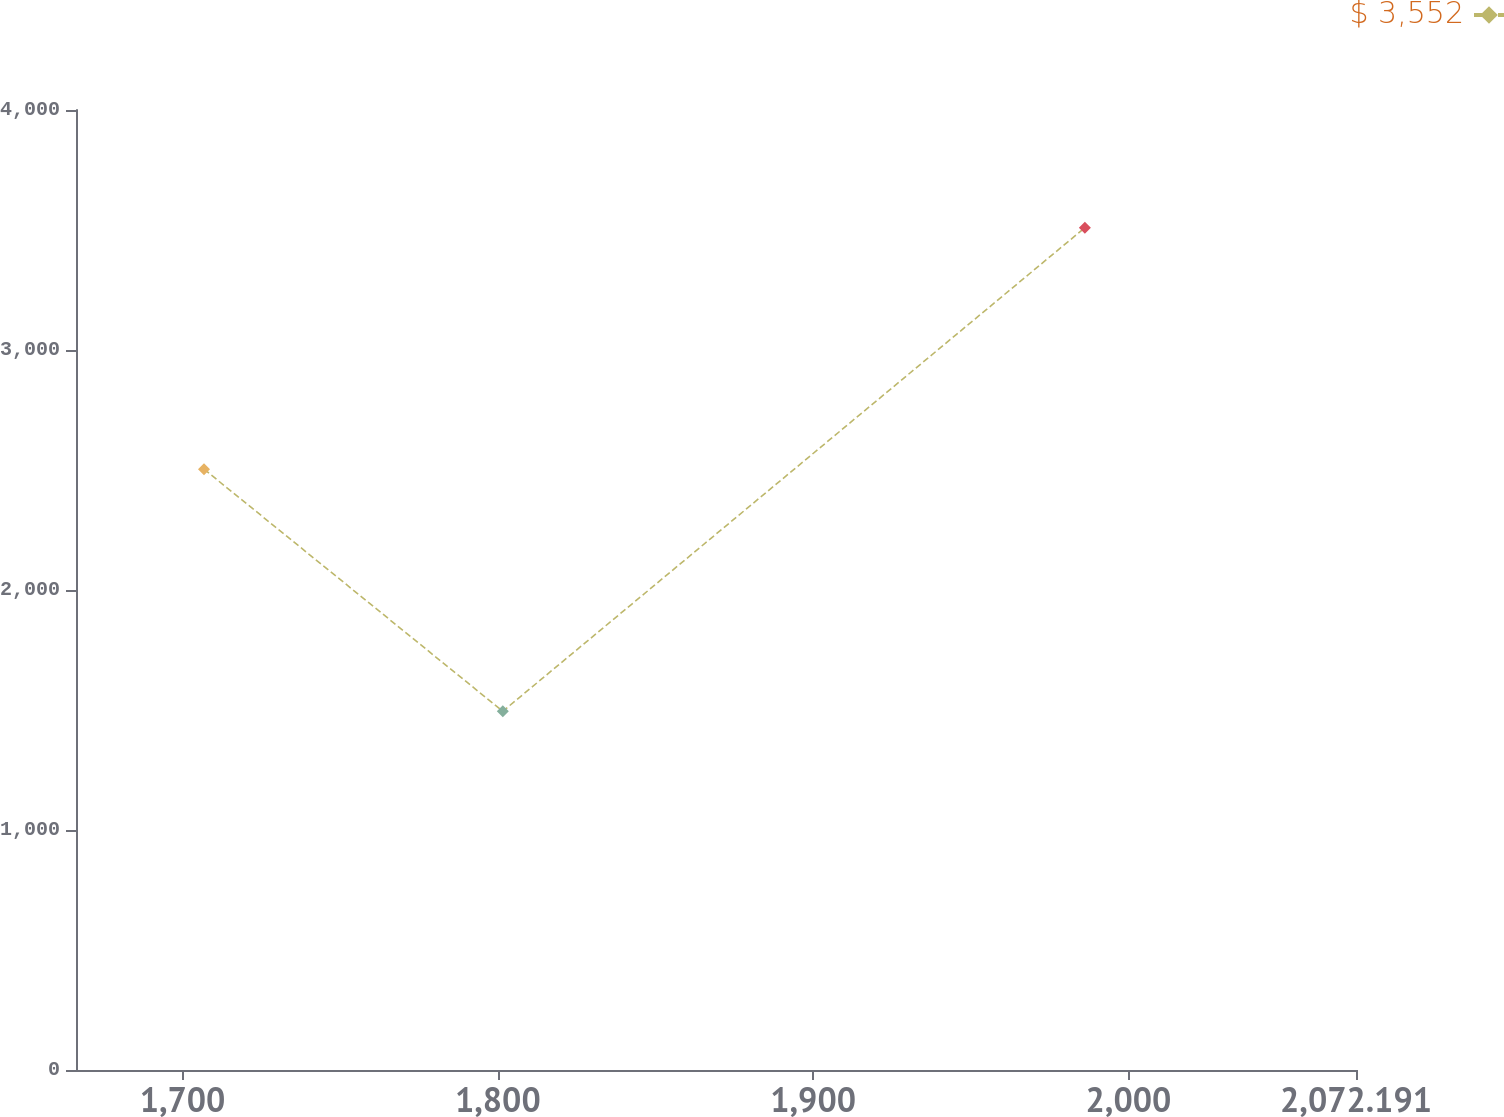Convert chart to OTSL. <chart><loc_0><loc_0><loc_500><loc_500><line_chart><ecel><fcel>$ 3,552<nl><fcel>1706.8<fcel>2503.5<nl><fcel>1801.57<fcel>1494.7<nl><fcel>1986.19<fcel>3509.44<nl><fcel>2112.79<fcel>1081.14<nl></chart> 